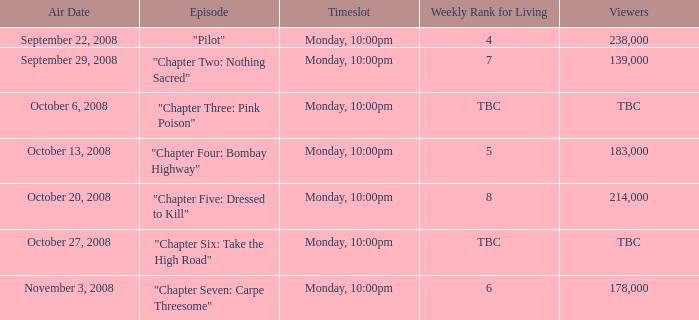What is the weekly rank for living when the air date is october 6, 2008? TBC. 